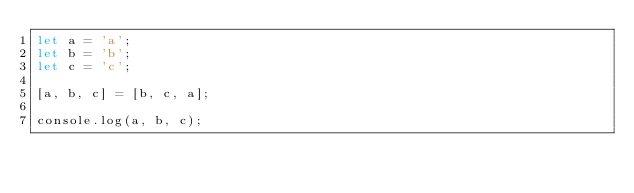Convert code to text. <code><loc_0><loc_0><loc_500><loc_500><_JavaScript_>let a = 'a';
let b = 'b';
let c = 'c';

[a, b, c] = [b, c, a];

console.log(a, b, c);</code> 